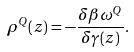Convert formula to latex. <formula><loc_0><loc_0><loc_500><loc_500>\rho ^ { Q } ( z ) = - \frac { \delta \beta \omega ^ { Q } } { \delta \gamma ( z ) } .</formula> 